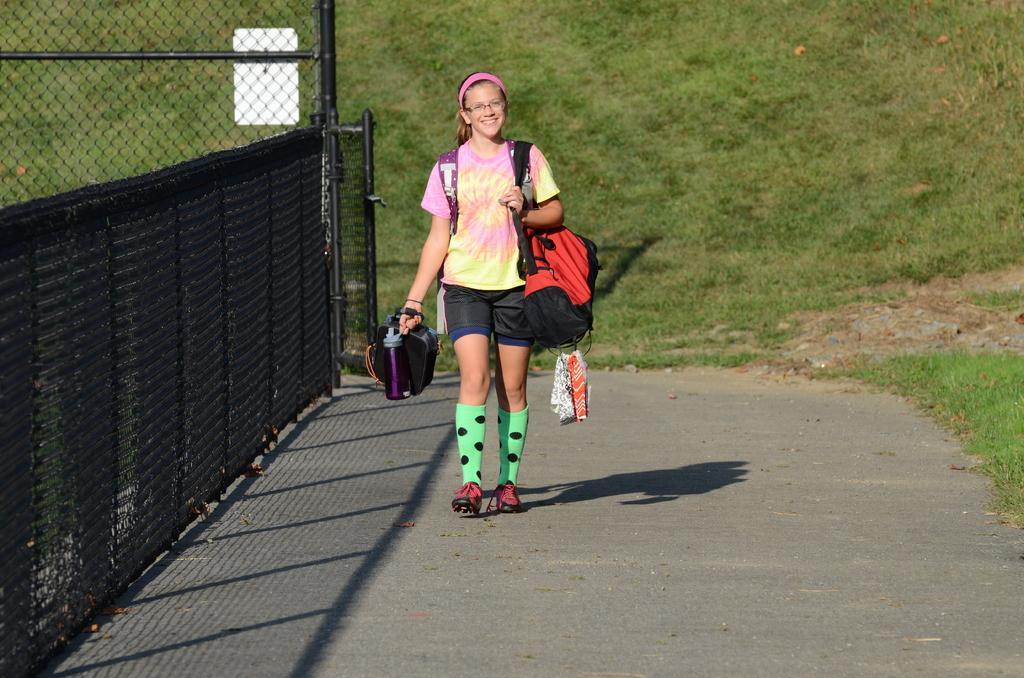Describe this image in one or two sentences. This is a girl holding a bag and bottle. She is walking and smiling. She wore a T-shirt, headband, spectacles, short, socks and shoes. This looks like a fence, which is black in color. Here is the grass. I can see the shadow of this girl. 